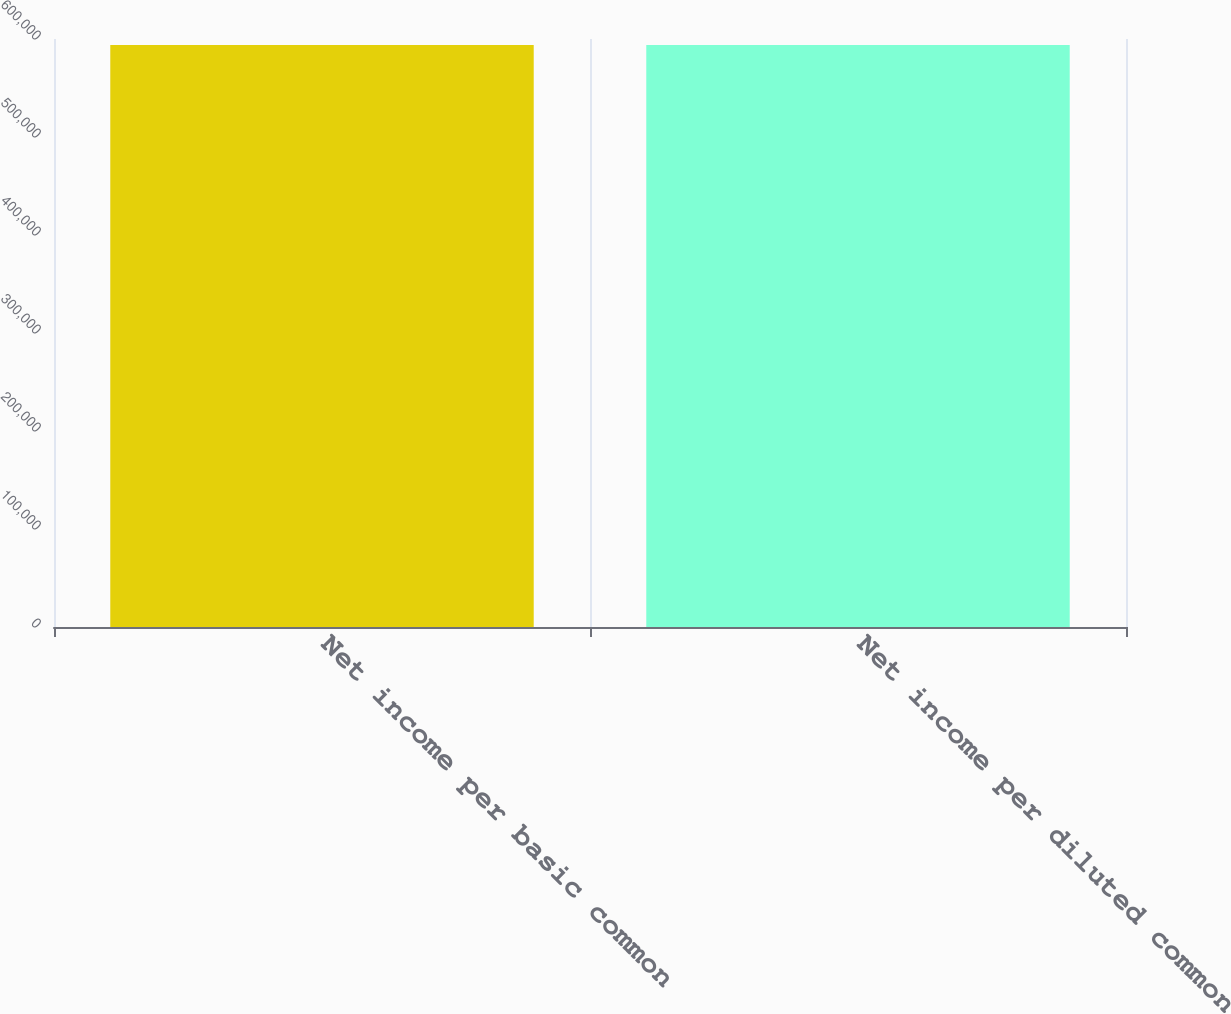Convert chart to OTSL. <chart><loc_0><loc_0><loc_500><loc_500><bar_chart><fcel>Net income per basic common<fcel>Net income per diluted common<nl><fcel>593794<fcel>593794<nl></chart> 